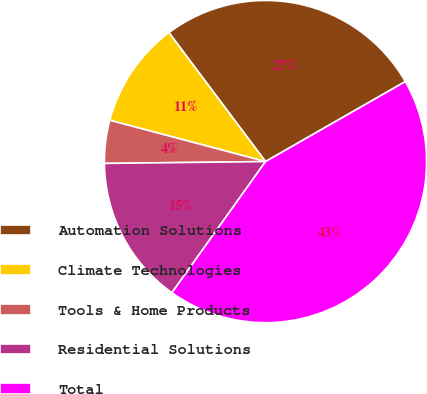Convert chart to OTSL. <chart><loc_0><loc_0><loc_500><loc_500><pie_chart><fcel>Automation Solutions<fcel>Climate Technologies<fcel>Tools & Home Products<fcel>Residential Solutions<fcel>Total<nl><fcel>26.96%<fcel>10.64%<fcel>4.31%<fcel>14.95%<fcel>43.14%<nl></chart> 